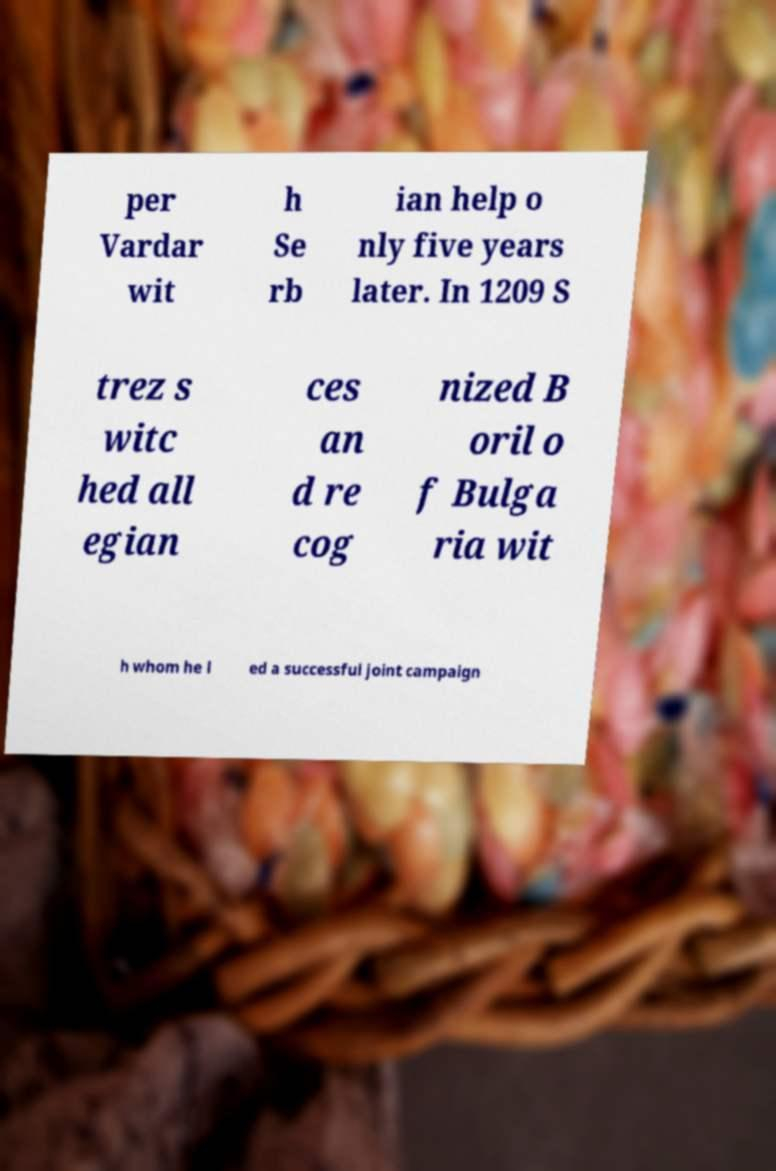Could you assist in decoding the text presented in this image and type it out clearly? per Vardar wit h Se rb ian help o nly five years later. In 1209 S trez s witc hed all egian ces an d re cog nized B oril o f Bulga ria wit h whom he l ed a successful joint campaign 